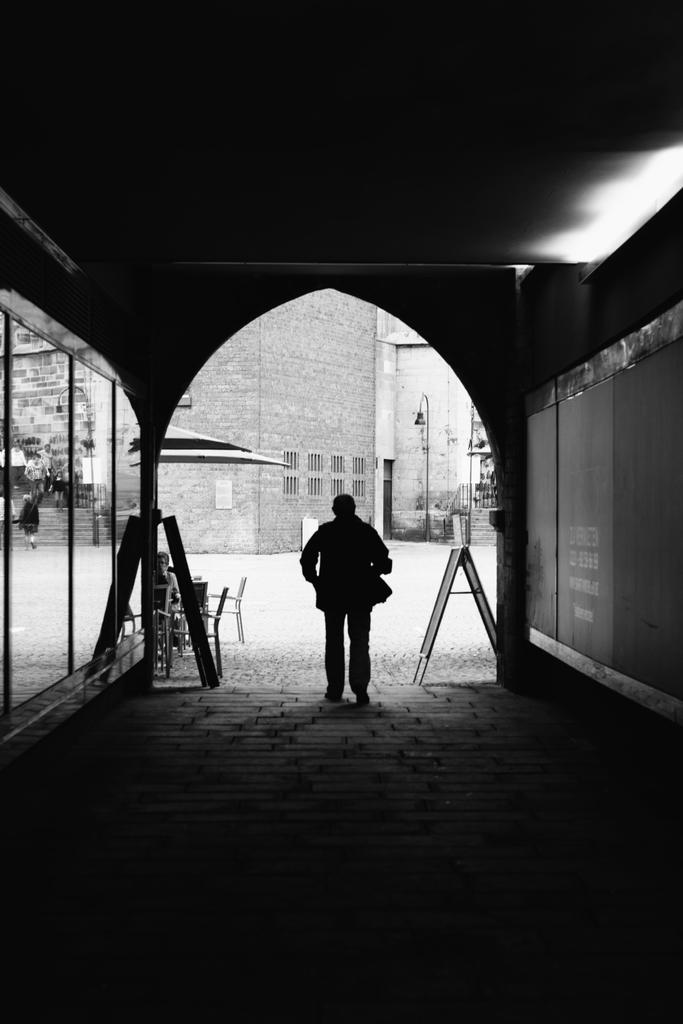What is the main subject of the image? There is a person standing in the image. Where is the person standing? The person is standing on the ground. What can be seen in the background of the image? There is a building in the background of the image. Are there any other people visible in the image? Yes, there are other persons visible in the background of the image. What type of animal is the person holding in the image? There is no animal present in the image. What color is the mitten that the person is wearing in the image? There is no mention of a mitten in the facts provided, and no mitten is visible in the image. 